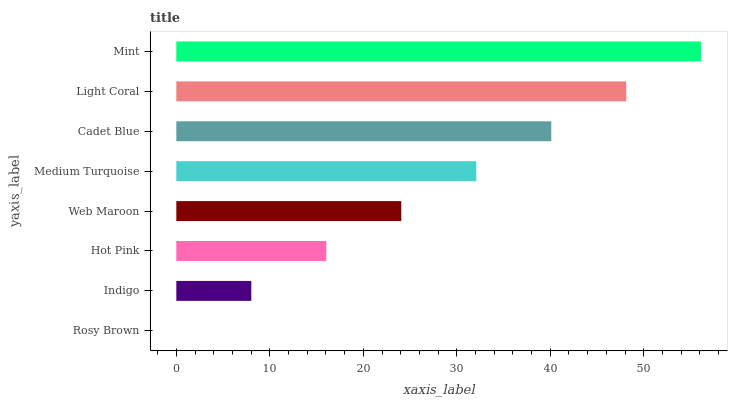Is Rosy Brown the minimum?
Answer yes or no. Yes. Is Mint the maximum?
Answer yes or no. Yes. Is Indigo the minimum?
Answer yes or no. No. Is Indigo the maximum?
Answer yes or no. No. Is Indigo greater than Rosy Brown?
Answer yes or no. Yes. Is Rosy Brown less than Indigo?
Answer yes or no. Yes. Is Rosy Brown greater than Indigo?
Answer yes or no. No. Is Indigo less than Rosy Brown?
Answer yes or no. No. Is Medium Turquoise the high median?
Answer yes or no. Yes. Is Web Maroon the low median?
Answer yes or no. Yes. Is Web Maroon the high median?
Answer yes or no. No. Is Indigo the low median?
Answer yes or no. No. 